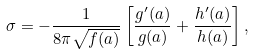<formula> <loc_0><loc_0><loc_500><loc_500>\sigma = - \frac { 1 } { 8 \pi \sqrt { f ( a ) } } \left [ \frac { g ^ { \prime } ( a ) } { g ( a ) } + \frac { h ^ { \prime } ( a ) } { h ( a ) } \right ] ,</formula> 